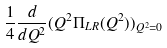<formula> <loc_0><loc_0><loc_500><loc_500>\frac { 1 } { 4 } \frac { d } { d Q ^ { 2 } } ( Q ^ { 2 } \Pi _ { L R } ( Q ^ { 2 } ) ) _ { Q ^ { 2 } = 0 }</formula> 